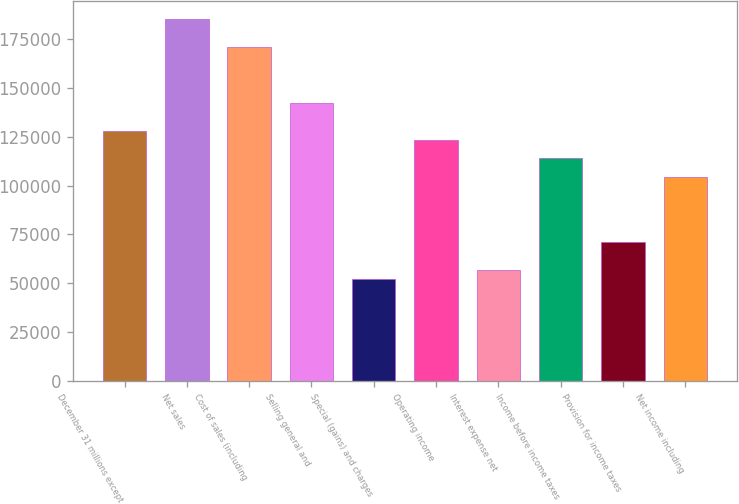Convert chart to OTSL. <chart><loc_0><loc_0><loc_500><loc_500><bar_chart><fcel>December 31 millions except<fcel>Net sales<fcel>Cost of sales (including<fcel>Selling general and<fcel>Special (gains) and charges<fcel>Operating income<fcel>Interest expense net<fcel>Income before income taxes<fcel>Provision for income taxes<fcel>Net income including<nl><fcel>128059<fcel>184973<fcel>170745<fcel>142288<fcel>52172.8<fcel>123316<fcel>56915.7<fcel>113830<fcel>71144.4<fcel>104345<nl></chart> 